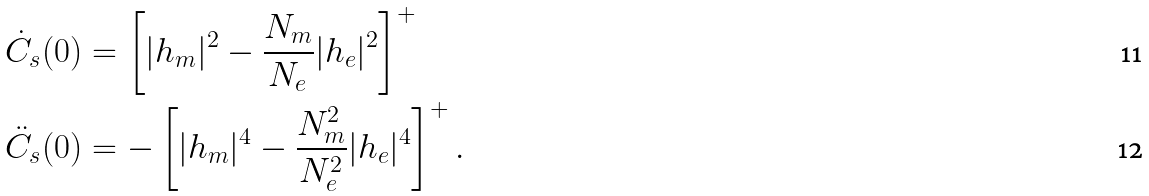<formula> <loc_0><loc_0><loc_500><loc_500>\dot { C } _ { s } ( 0 ) & = \left [ | h _ { m } | ^ { 2 } - \frac { N _ { m } } { N _ { e } } | h _ { e } | ^ { 2 } \right ] ^ { + } \\ \ddot { C } _ { s } ( 0 ) & = - \left [ | h _ { m } | ^ { 4 } - \frac { N _ { m } ^ { 2 } } { N _ { e } ^ { 2 } } | h _ { e } | ^ { 4 } \right ] ^ { + } .</formula> 